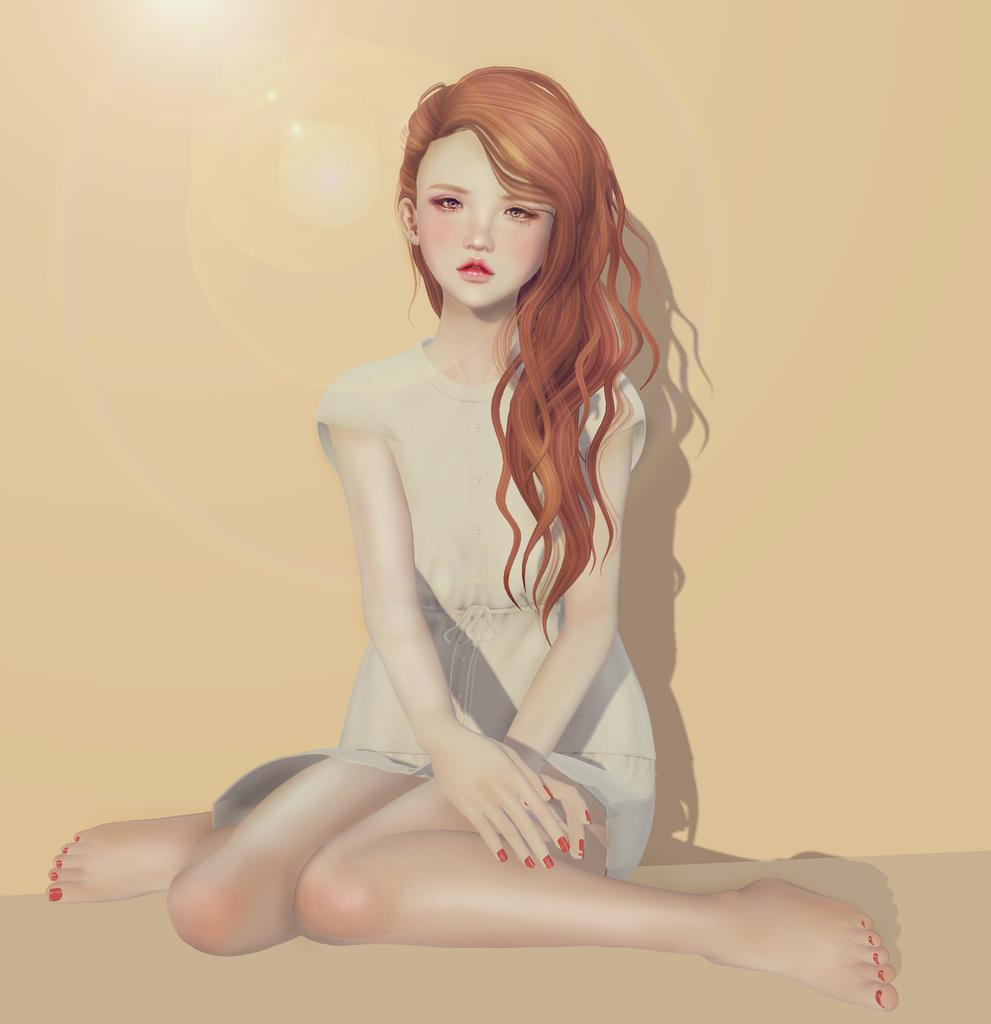What type of image is being described? The image is animated. Who is present in the image? There is a woman in the image. What is the woman doing in the image? The woman is sitting on the floor. Where is the woman located in the image? The woman is near a wall. How many babies are being educated in the image? There are no babies present in the image, so it is not possible to determine how they might be educated. 